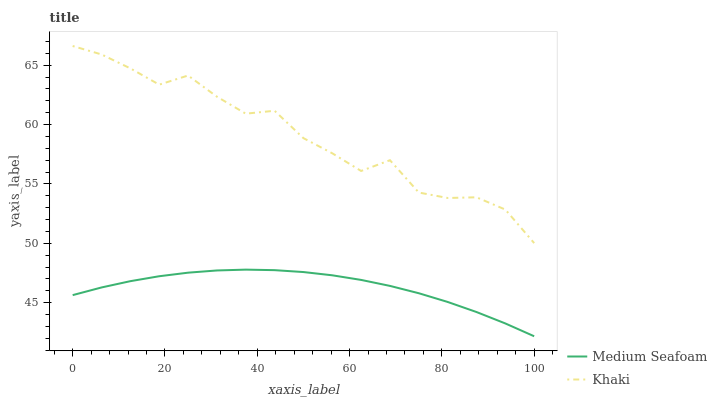Does Medium Seafoam have the minimum area under the curve?
Answer yes or no. Yes. Does Khaki have the maximum area under the curve?
Answer yes or no. Yes. Does Medium Seafoam have the maximum area under the curve?
Answer yes or no. No. Is Medium Seafoam the smoothest?
Answer yes or no. Yes. Is Khaki the roughest?
Answer yes or no. Yes. Is Medium Seafoam the roughest?
Answer yes or no. No. Does Medium Seafoam have the lowest value?
Answer yes or no. Yes. Does Khaki have the highest value?
Answer yes or no. Yes. Does Medium Seafoam have the highest value?
Answer yes or no. No. Is Medium Seafoam less than Khaki?
Answer yes or no. Yes. Is Khaki greater than Medium Seafoam?
Answer yes or no. Yes. Does Medium Seafoam intersect Khaki?
Answer yes or no. No. 